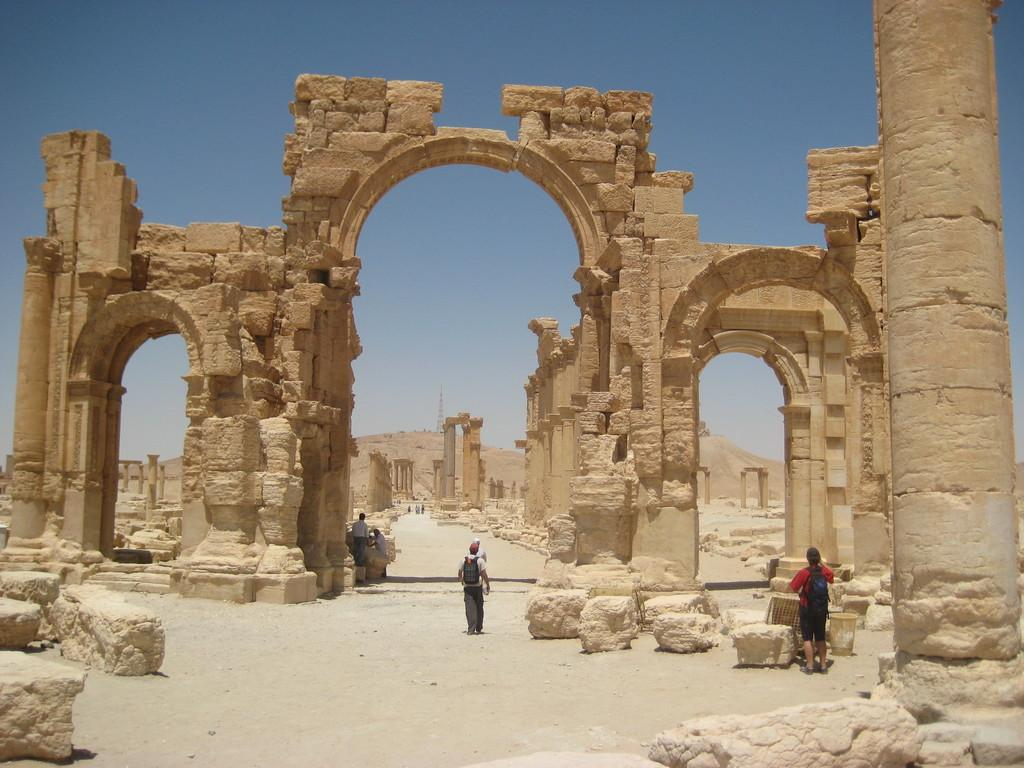What type of structures can be seen in the image? There are monuments in the image. What natural elements are present in the image? There are rocks and land visible in the image. What are the people in the image wearing? The people in the image are wearing bags. What can be seen in the background of the image? The sky is visible in the background of the image. What type of dinner is being served in the image? There is no dinner present in the image; it features monuments, rocks, land, people wearing bags, and the sky. Can you tell me where the library is located in the image? There is no library present in the image. 